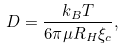Convert formula to latex. <formula><loc_0><loc_0><loc_500><loc_500>D = \frac { k _ { B } T } { 6 \pi \mu R _ { H } \xi _ { c } } ,</formula> 